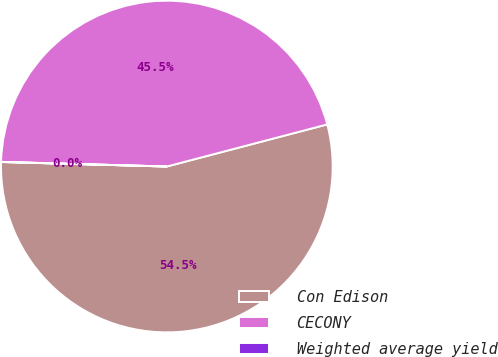Convert chart. <chart><loc_0><loc_0><loc_500><loc_500><pie_chart><fcel>Con Edison<fcel>CECONY<fcel>Weighted average yield<nl><fcel>54.52%<fcel>45.47%<fcel>0.01%<nl></chart> 